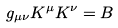Convert formula to latex. <formula><loc_0><loc_0><loc_500><loc_500>g _ { \mu \nu } K ^ { \mu } K ^ { \nu } = B</formula> 